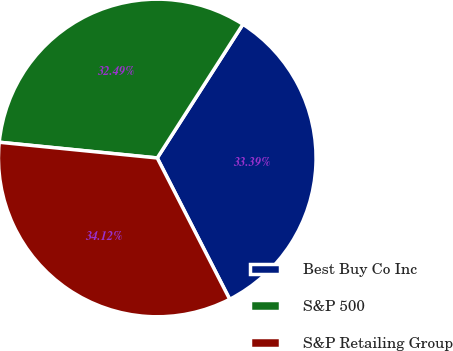Convert chart. <chart><loc_0><loc_0><loc_500><loc_500><pie_chart><fcel>Best Buy Co Inc<fcel>S&P 500<fcel>S&P Retailing Group<nl><fcel>33.39%<fcel>32.49%<fcel>34.12%<nl></chart> 